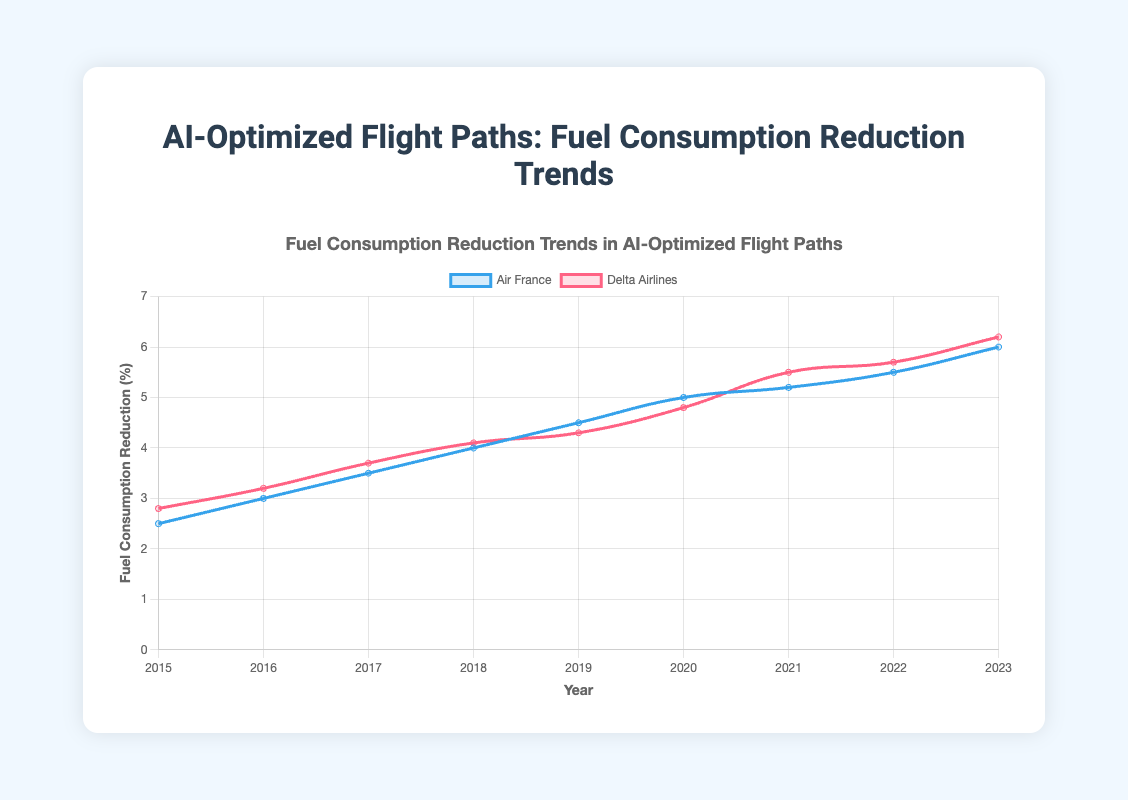What is the overall trend in fuel consumption reduction for both airlines from 2015 to 2023? The overall trend for both Air France and Delta Airlines shows an increasing reduction in fuel consumption over the years from 2015 to 2023. Air France starts at 2.5% in 2015 and ends at 6.0% in 2023. Delta Airlines starts at 2.8% in 2015 and ends at 6.2% in 2023.
Answer: Increasing Which airline had the higher fuel consumption reduction percentage in 2023? In 2023, Delta Airlines had a higher fuel consumption reduction percentage (6.2%) compared to Air France (6.0%).
Answer: Delta Airlines How much did Air France's fuel consumption reduction percentage increase from 2015 to 2023? Air France's reduction percentage increased from 2.5% in 2015 to 6.0% in 2023. The increase is calculated as 6.0% - 2.5%.
Answer: 3.5% In which year did Delta Airlines see the smallest increase in fuel consumption reduction percentage compared to the previous year? To find the smallest increase, we compare Delta Airlines' data year by year. The smallest increase occurs from 2019 (4.3%) to 2020 (4.8%), which is an increase of 0.5%.
Answer: 2020 Compare the average fuel consumption reduction percentages for both airlines from 2015 to 2023. Which airline has a higher average reduction? Calculate the average reduction for each airline. For Air France: (2.5 + 3.0 + 3.5 + 4.0 + 4.5 + 5.0 + 5.2 + 5.5 + 6.0) / 9 = 4.47%. For Delta Airlines: (2.8 + 3.2 + 3.7 + 4.1 + 4.3 + 4.8 + 5.5 + 5.7 + 6.2) / 9 = 4.7%. Delta Airlines has a higher average reduction.
Answer: Delta Airlines Which airline showed a consistent year-over-year increase in fuel consumption reduction percentages without any drop from the previous year? Both airlines show a consistent year-over-year increase in fuel consumption reduction percentages without any drop from the previous year.
Answer: Both Air France and Delta Airlines In 2021, which airline had a greater fuel consumption reduction percentage and what was the difference? In 2021, Delta Airlines had a reduction percentage of 5.5%, and Air France had 5.2%. The difference is 5.5% - 5.2%.
Answer: Delta Airlines, 0.3% Which year did Air France first reach a 5.0% reduction in fuel consumption? Air France first reached a 5.0% reduction in fuel consumption in the year 2020.
Answer: 2020 What is the difference in fuel consumption reduction between Air France and Delta Airlines in 2019? In 2019, Air France had a reduction percentage of 4.5%, and Delta Airlines had 4.3%. The difference is 4.5% - 4.3%.
Answer: 0.2% Compare the slope of the trend lines for both airlines. Which airline shows a steeper increase in fuel consumption reduction from 2015 to 2023? The slopes are calculated by the change in reduction percentage over the years. Air France's change is (6.0% - 2.5%) / 8 = 0.4375 per year. Delta Airlines' change is (6.2% - 2.8%) / 8 = 0.425 per year. Air France shows a steeper increase.
Answer: Air France 